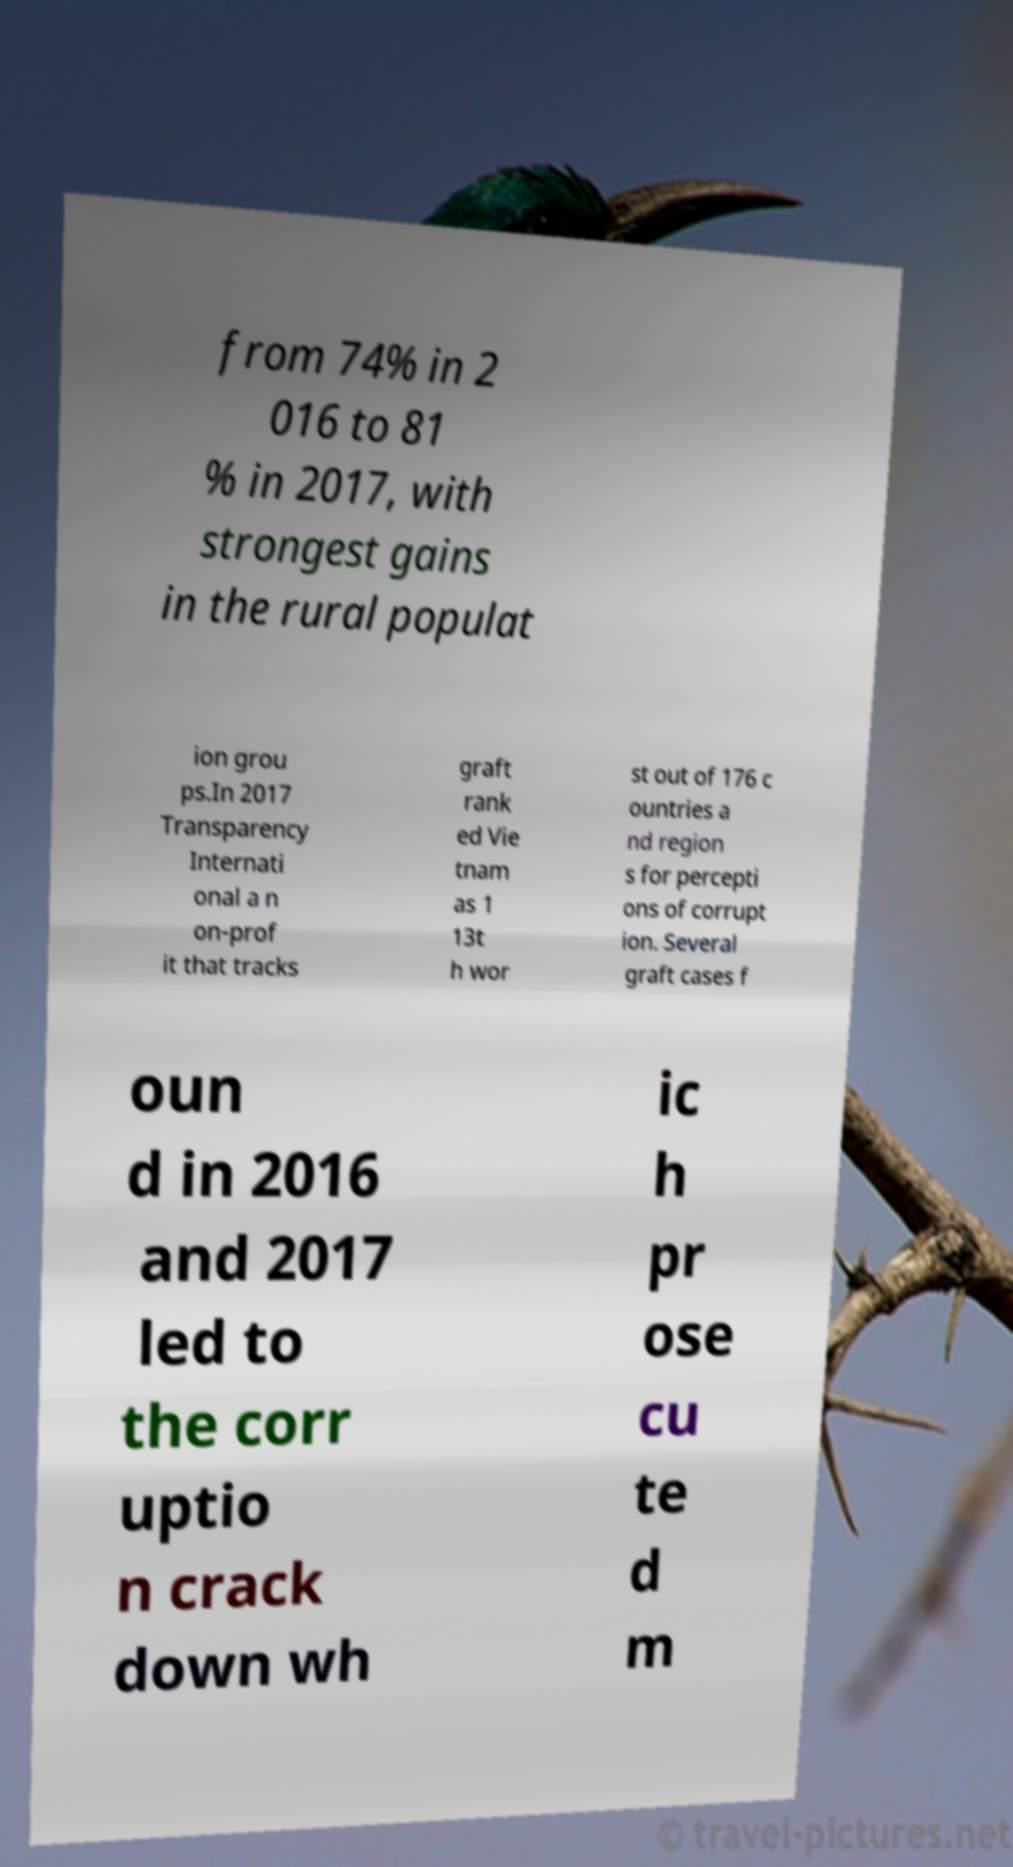For documentation purposes, I need the text within this image transcribed. Could you provide that? from 74% in 2 016 to 81 % in 2017, with strongest gains in the rural populat ion grou ps.In 2017 Transparency Internati onal a n on-prof it that tracks graft rank ed Vie tnam as 1 13t h wor st out of 176 c ountries a nd region s for percepti ons of corrupt ion. Several graft cases f oun d in 2016 and 2017 led to the corr uptio n crack down wh ic h pr ose cu te d m 